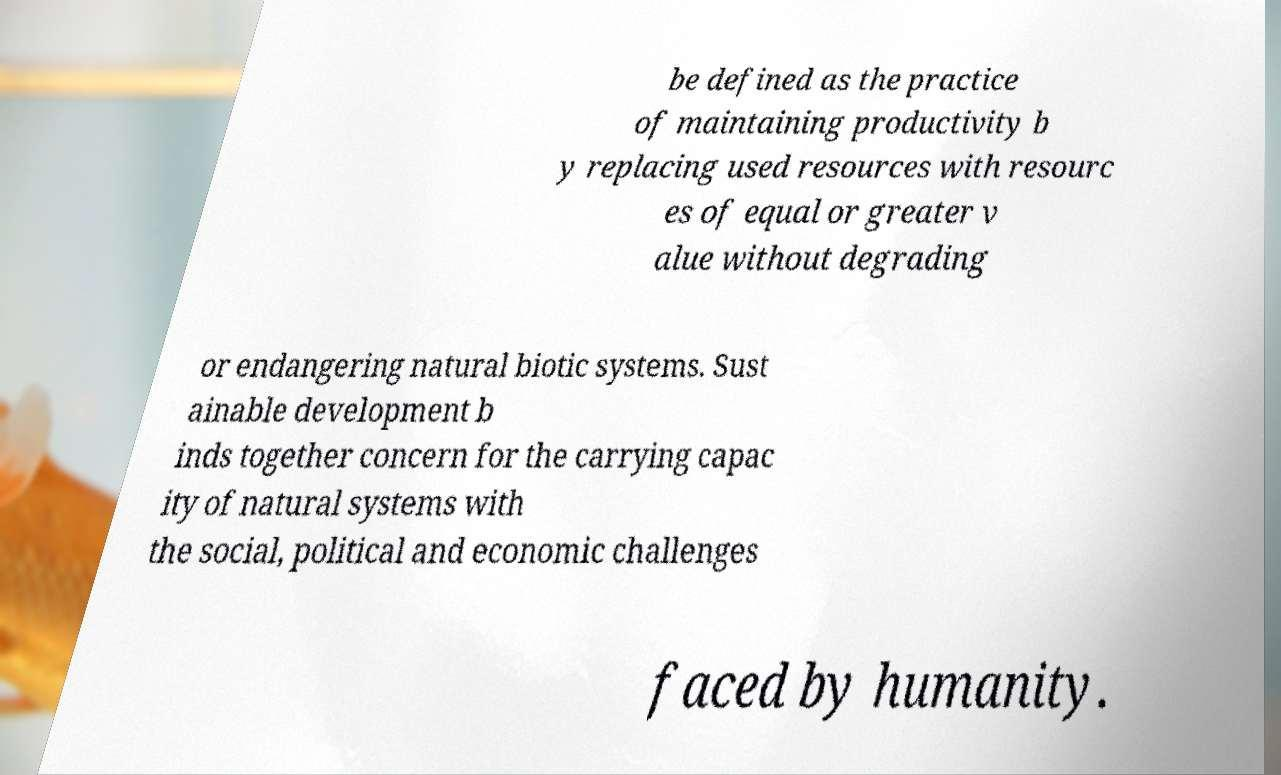For documentation purposes, I need the text within this image transcribed. Could you provide that? be defined as the practice of maintaining productivity b y replacing used resources with resourc es of equal or greater v alue without degrading or endangering natural biotic systems. Sust ainable development b inds together concern for the carrying capac ity of natural systems with the social, political and economic challenges faced by humanity. 